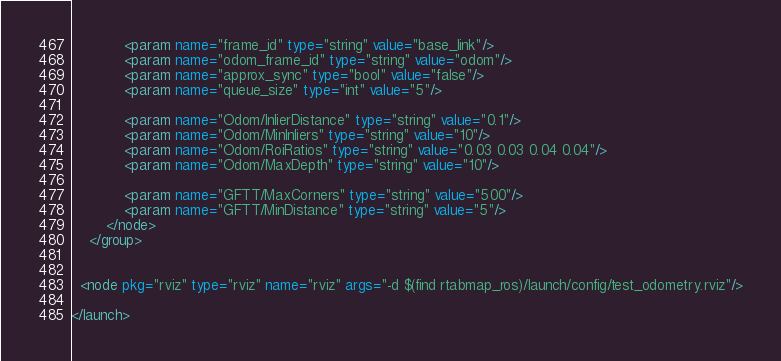Convert code to text. <code><loc_0><loc_0><loc_500><loc_500><_XML_>	  	  	<param name="frame_id" type="string" value="base_link"/>
	  	  	<param name="odom_frame_id" type="string" value="odom"/>
	  	  	<param name="approx_sync" type="bool" value="false"/>
	  	  	<param name="queue_size" type="int" value="5"/>

			<param name="Odom/InlierDistance" type="string" value="0.1"/>
	  		<param name="Odom/MinInliers" type="string" value="10"/>
	  		<param name="Odom/RoiRatios" type="string" value="0.03 0.03 0.04 0.04"/>
	  		<param name="Odom/MaxDepth" type="string" value="10"/>
      
	  		<param name="GFTT/MaxCorners" type="string" value="500"/>
	  		<param name="GFTT/MinDistance" type="string" value="5"/>
	  	</node>		
	</group>
  
  
  <node pkg="rviz" type="rviz" name="rviz" args="-d $(find rtabmap_ros)/launch/config/test_odometry.rviz"/>
  
</launch></code> 